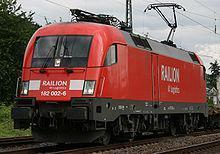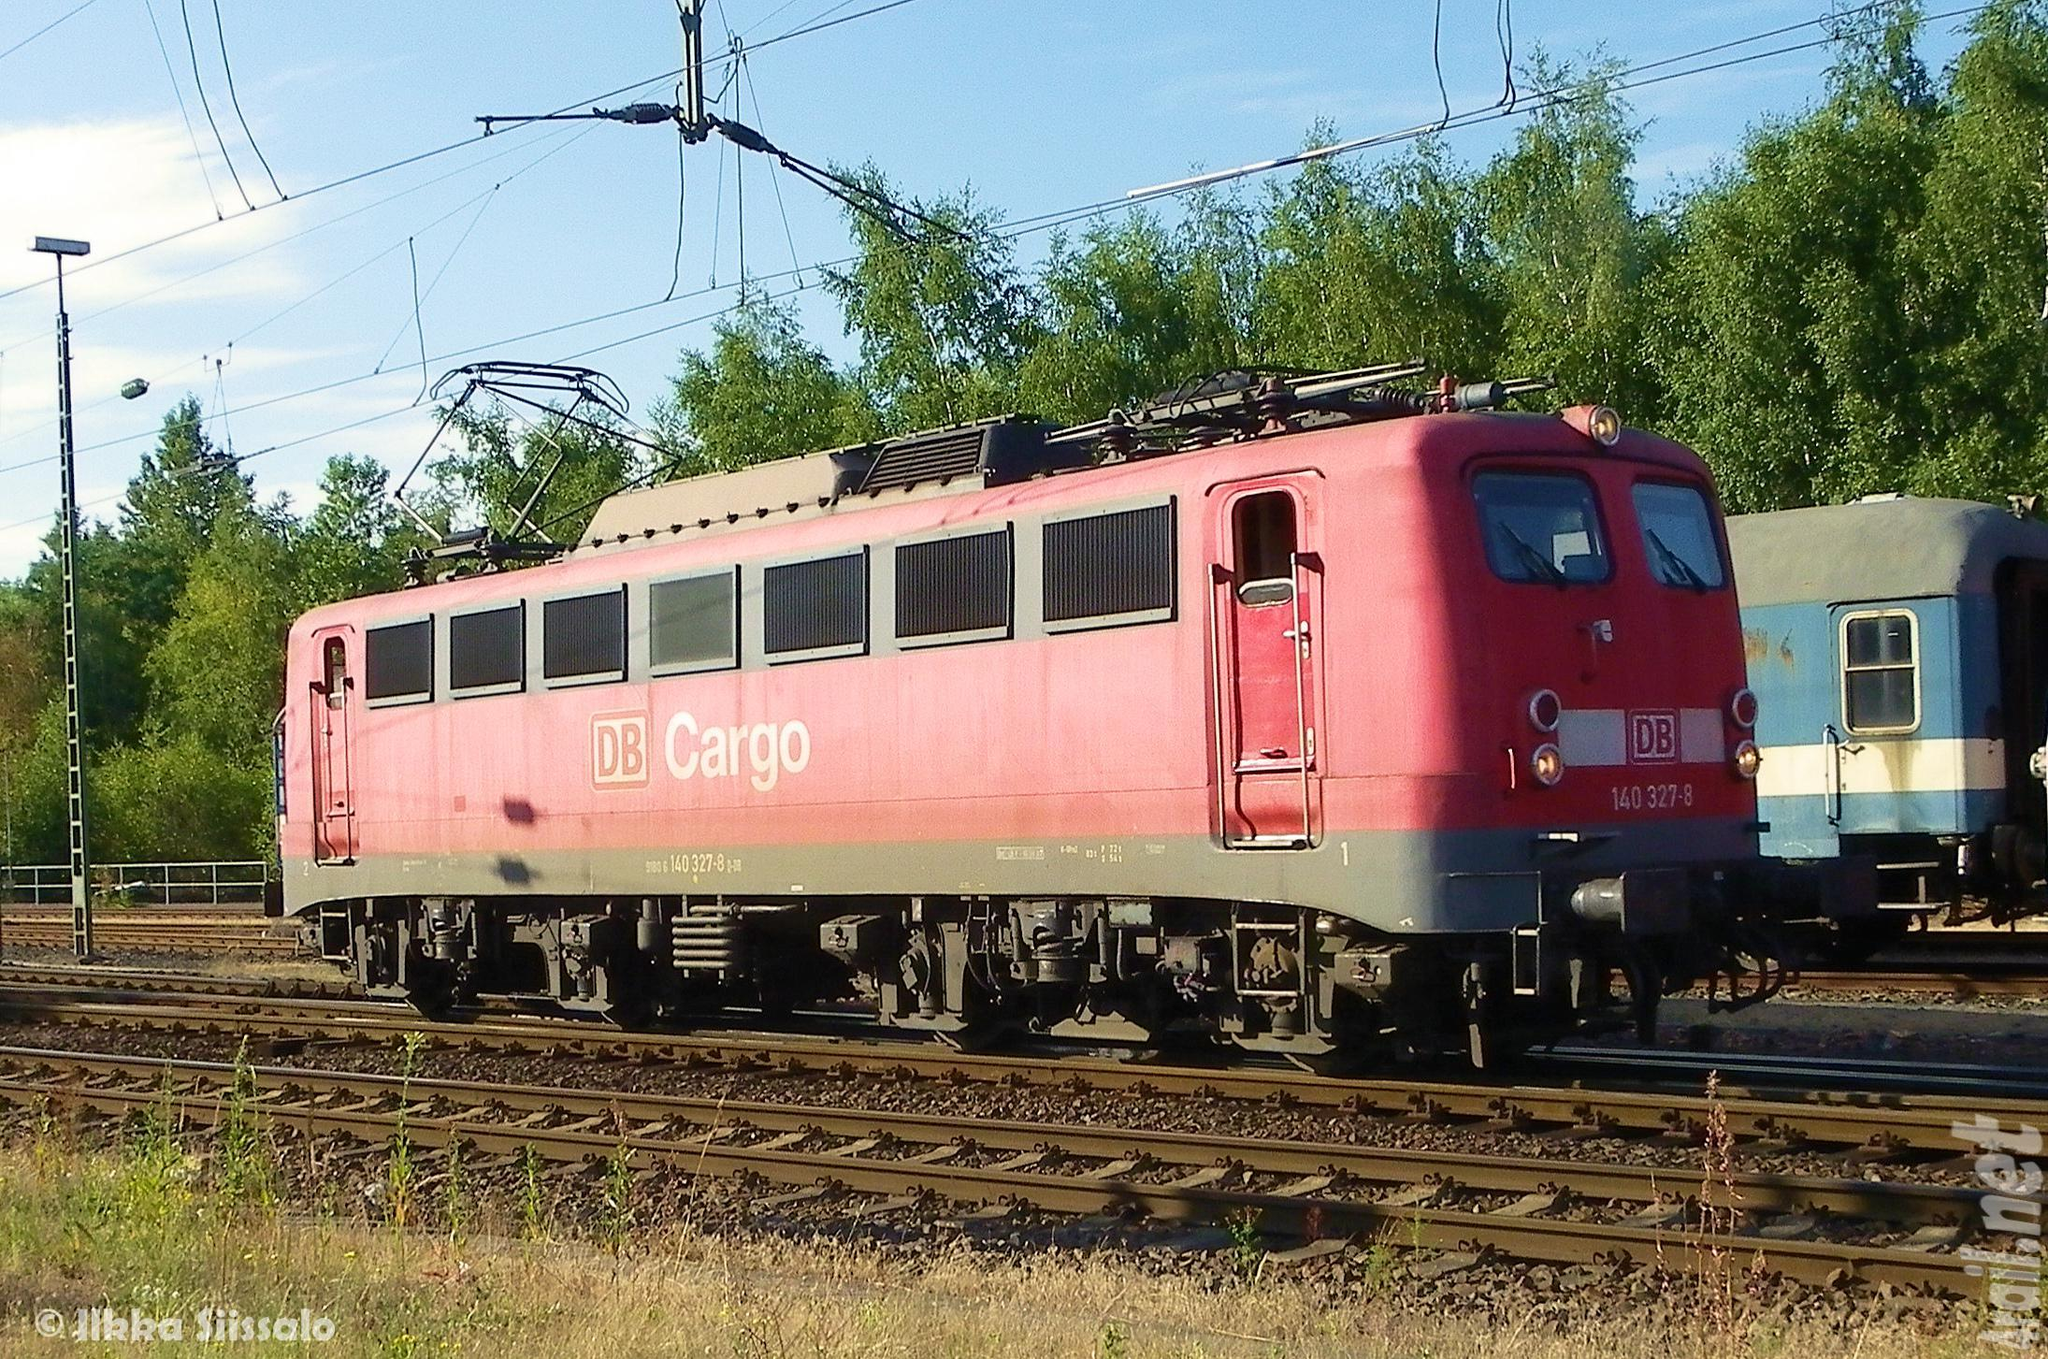The first image is the image on the left, the second image is the image on the right. For the images displayed, is the sentence "The train in one of the images is black with red rims." factually correct? Answer yes or no. No. The first image is the image on the left, the second image is the image on the right. Examine the images to the left and right. Is the description "Each image includes one predominantly red train on a track." accurate? Answer yes or no. Yes. 